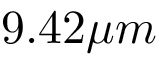Convert formula to latex. <formula><loc_0><loc_0><loc_500><loc_500>9 . 4 2 \mu m</formula> 